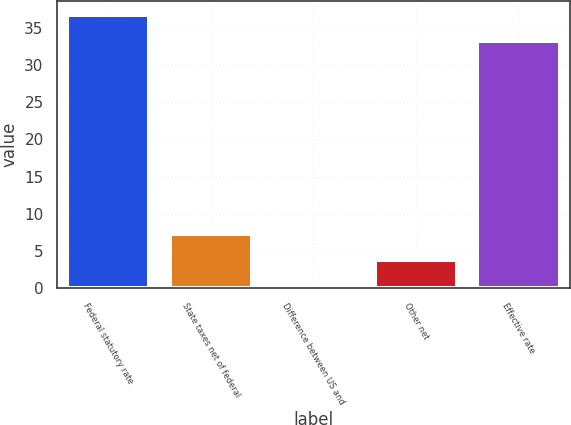Convert chart. <chart><loc_0><loc_0><loc_500><loc_500><bar_chart><fcel>Federal statutory rate<fcel>State taxes net of federal<fcel>Difference between US and<fcel>Other net<fcel>Effective rate<nl><fcel>36.77<fcel>7.24<fcel>0.3<fcel>3.77<fcel>33.3<nl></chart> 